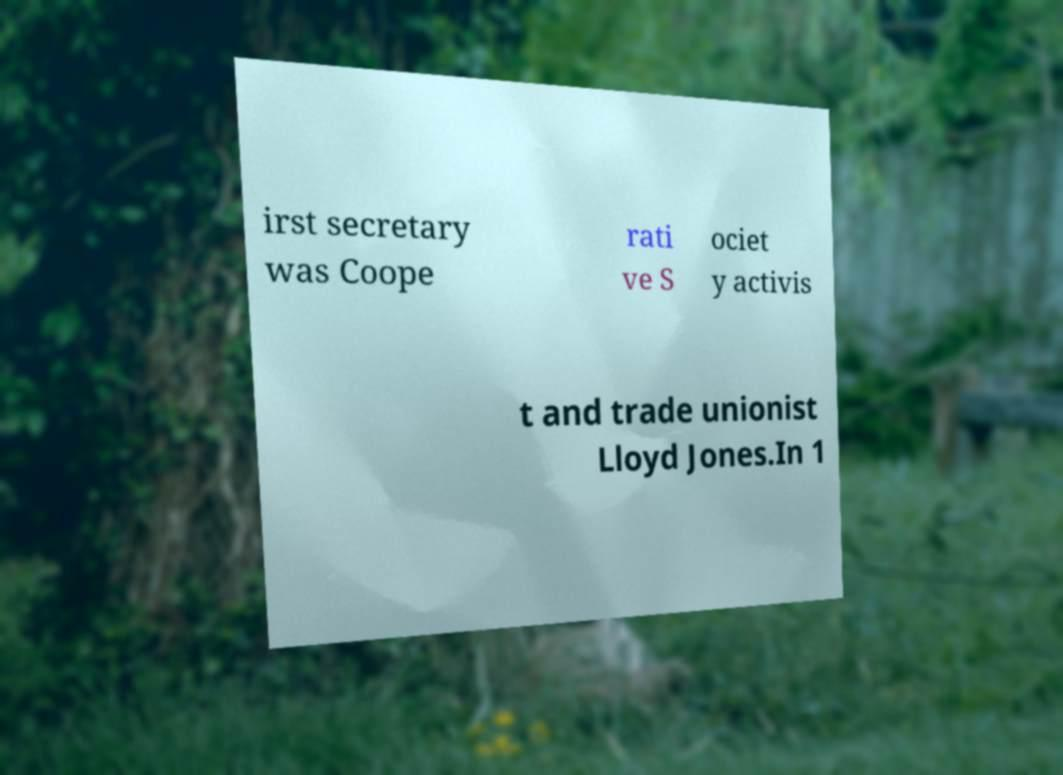Could you assist in decoding the text presented in this image and type it out clearly? irst secretary was Coope rati ve S ociet y activis t and trade unionist Lloyd Jones.In 1 